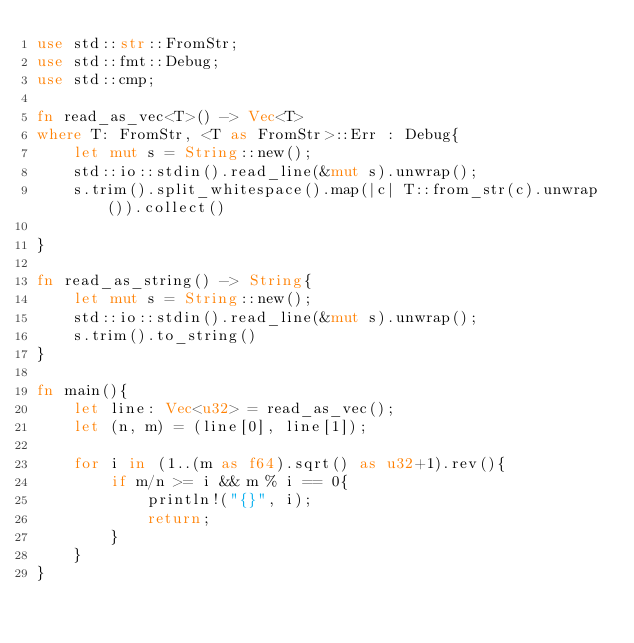Convert code to text. <code><loc_0><loc_0><loc_500><loc_500><_Rust_>use std::str::FromStr;
use std::fmt::Debug;
use std::cmp;

fn read_as_vec<T>() -> Vec<T>
where T: FromStr, <T as FromStr>::Err : Debug{
    let mut s = String::new();
    std::io::stdin().read_line(&mut s).unwrap();
    s.trim().split_whitespace().map(|c| T::from_str(c).unwrap()).collect()

}

fn read_as_string() -> String{
    let mut s = String::new();
    std::io::stdin().read_line(&mut s).unwrap();
    s.trim().to_string()
}

fn main(){
    let line: Vec<u32> = read_as_vec();
    let (n, m) = (line[0], line[1]);

    for i in (1..(m as f64).sqrt() as u32+1).rev(){
        if m/n >= i && m % i == 0{
            println!("{}", i);
            return;
        }
    }
}
</code> 